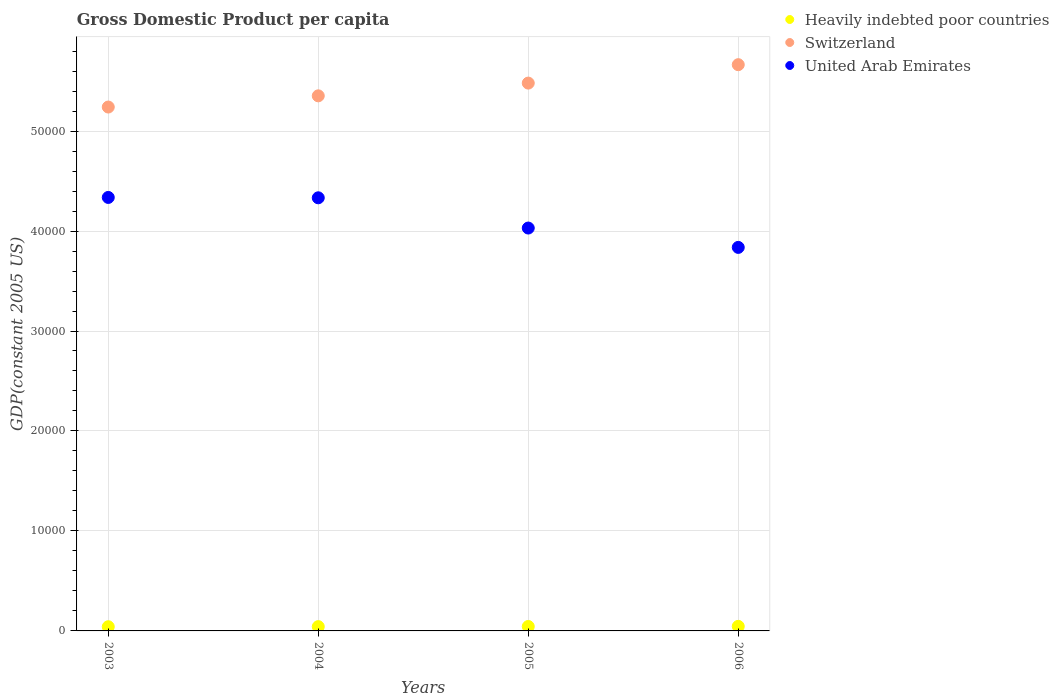How many different coloured dotlines are there?
Give a very brief answer. 3. What is the GDP per capita in Switzerland in 2004?
Make the answer very short. 5.35e+04. Across all years, what is the maximum GDP per capita in Switzerland?
Your answer should be compact. 5.66e+04. Across all years, what is the minimum GDP per capita in Switzerland?
Offer a terse response. 5.24e+04. In which year was the GDP per capita in United Arab Emirates maximum?
Your response must be concise. 2003. In which year was the GDP per capita in United Arab Emirates minimum?
Keep it short and to the point. 2006. What is the total GDP per capita in Switzerland in the graph?
Give a very brief answer. 2.17e+05. What is the difference between the GDP per capita in Heavily indebted poor countries in 2004 and that in 2006?
Keep it short and to the point. -26.72. What is the difference between the GDP per capita in Heavily indebted poor countries in 2006 and the GDP per capita in United Arab Emirates in 2004?
Offer a terse response. -4.29e+04. What is the average GDP per capita in Switzerland per year?
Make the answer very short. 5.43e+04. In the year 2005, what is the difference between the GDP per capita in Switzerland and GDP per capita in Heavily indebted poor countries?
Provide a short and direct response. 5.44e+04. In how many years, is the GDP per capita in Heavily indebted poor countries greater than 10000 US$?
Offer a terse response. 0. What is the ratio of the GDP per capita in United Arab Emirates in 2004 to that in 2006?
Your response must be concise. 1.13. What is the difference between the highest and the second highest GDP per capita in Switzerland?
Ensure brevity in your answer.  1842.34. What is the difference between the highest and the lowest GDP per capita in Switzerland?
Your answer should be compact. 4236.97. In how many years, is the GDP per capita in Heavily indebted poor countries greater than the average GDP per capita in Heavily indebted poor countries taken over all years?
Offer a terse response. 2. Is the sum of the GDP per capita in United Arab Emirates in 2003 and 2006 greater than the maximum GDP per capita in Switzerland across all years?
Make the answer very short. Yes. Is it the case that in every year, the sum of the GDP per capita in Switzerland and GDP per capita in Heavily indebted poor countries  is greater than the GDP per capita in United Arab Emirates?
Offer a very short reply. Yes. How many dotlines are there?
Provide a short and direct response. 3. What is the difference between two consecutive major ticks on the Y-axis?
Offer a terse response. 10000. Are the values on the major ticks of Y-axis written in scientific E-notation?
Offer a very short reply. No. Does the graph contain grids?
Keep it short and to the point. Yes. How are the legend labels stacked?
Your response must be concise. Vertical. What is the title of the graph?
Provide a succinct answer. Gross Domestic Product per capita. Does "Central Europe" appear as one of the legend labels in the graph?
Your response must be concise. No. What is the label or title of the X-axis?
Ensure brevity in your answer.  Years. What is the label or title of the Y-axis?
Offer a very short reply. GDP(constant 2005 US). What is the GDP(constant 2005 US) of Heavily indebted poor countries in 2003?
Make the answer very short. 419.1. What is the GDP(constant 2005 US) in Switzerland in 2003?
Ensure brevity in your answer.  5.24e+04. What is the GDP(constant 2005 US) in United Arab Emirates in 2003?
Offer a terse response. 4.34e+04. What is the GDP(constant 2005 US) of Heavily indebted poor countries in 2004?
Your answer should be very brief. 429.73. What is the GDP(constant 2005 US) in Switzerland in 2004?
Offer a very short reply. 5.35e+04. What is the GDP(constant 2005 US) of United Arab Emirates in 2004?
Offer a very short reply. 4.33e+04. What is the GDP(constant 2005 US) in Heavily indebted poor countries in 2005?
Ensure brevity in your answer.  443.25. What is the GDP(constant 2005 US) of Switzerland in 2005?
Ensure brevity in your answer.  5.48e+04. What is the GDP(constant 2005 US) of United Arab Emirates in 2005?
Your answer should be very brief. 4.03e+04. What is the GDP(constant 2005 US) in Heavily indebted poor countries in 2006?
Your response must be concise. 456.45. What is the GDP(constant 2005 US) in Switzerland in 2006?
Make the answer very short. 5.66e+04. What is the GDP(constant 2005 US) in United Arab Emirates in 2006?
Give a very brief answer. 3.84e+04. Across all years, what is the maximum GDP(constant 2005 US) in Heavily indebted poor countries?
Give a very brief answer. 456.45. Across all years, what is the maximum GDP(constant 2005 US) of Switzerland?
Offer a terse response. 5.66e+04. Across all years, what is the maximum GDP(constant 2005 US) of United Arab Emirates?
Give a very brief answer. 4.34e+04. Across all years, what is the minimum GDP(constant 2005 US) in Heavily indebted poor countries?
Your response must be concise. 419.1. Across all years, what is the minimum GDP(constant 2005 US) in Switzerland?
Provide a succinct answer. 5.24e+04. Across all years, what is the minimum GDP(constant 2005 US) of United Arab Emirates?
Make the answer very short. 3.84e+04. What is the total GDP(constant 2005 US) in Heavily indebted poor countries in the graph?
Your answer should be compact. 1748.53. What is the total GDP(constant 2005 US) in Switzerland in the graph?
Provide a short and direct response. 2.17e+05. What is the total GDP(constant 2005 US) of United Arab Emirates in the graph?
Offer a very short reply. 1.65e+05. What is the difference between the GDP(constant 2005 US) of Heavily indebted poor countries in 2003 and that in 2004?
Your answer should be very brief. -10.63. What is the difference between the GDP(constant 2005 US) in Switzerland in 2003 and that in 2004?
Your answer should be very brief. -1120.59. What is the difference between the GDP(constant 2005 US) of United Arab Emirates in 2003 and that in 2004?
Give a very brief answer. 35.85. What is the difference between the GDP(constant 2005 US) of Heavily indebted poor countries in 2003 and that in 2005?
Provide a succinct answer. -24.15. What is the difference between the GDP(constant 2005 US) in Switzerland in 2003 and that in 2005?
Offer a terse response. -2394.63. What is the difference between the GDP(constant 2005 US) in United Arab Emirates in 2003 and that in 2005?
Make the answer very short. 3061.33. What is the difference between the GDP(constant 2005 US) of Heavily indebted poor countries in 2003 and that in 2006?
Provide a short and direct response. -37.35. What is the difference between the GDP(constant 2005 US) in Switzerland in 2003 and that in 2006?
Your response must be concise. -4236.97. What is the difference between the GDP(constant 2005 US) in United Arab Emirates in 2003 and that in 2006?
Give a very brief answer. 4996.85. What is the difference between the GDP(constant 2005 US) in Heavily indebted poor countries in 2004 and that in 2005?
Ensure brevity in your answer.  -13.52. What is the difference between the GDP(constant 2005 US) of Switzerland in 2004 and that in 2005?
Your answer should be very brief. -1274.05. What is the difference between the GDP(constant 2005 US) of United Arab Emirates in 2004 and that in 2005?
Your answer should be compact. 3025.48. What is the difference between the GDP(constant 2005 US) of Heavily indebted poor countries in 2004 and that in 2006?
Your answer should be compact. -26.72. What is the difference between the GDP(constant 2005 US) in Switzerland in 2004 and that in 2006?
Provide a succinct answer. -3116.39. What is the difference between the GDP(constant 2005 US) in United Arab Emirates in 2004 and that in 2006?
Your answer should be compact. 4961. What is the difference between the GDP(constant 2005 US) in Heavily indebted poor countries in 2005 and that in 2006?
Ensure brevity in your answer.  -13.2. What is the difference between the GDP(constant 2005 US) in Switzerland in 2005 and that in 2006?
Provide a succinct answer. -1842.34. What is the difference between the GDP(constant 2005 US) of United Arab Emirates in 2005 and that in 2006?
Your answer should be compact. 1935.52. What is the difference between the GDP(constant 2005 US) in Heavily indebted poor countries in 2003 and the GDP(constant 2005 US) in Switzerland in 2004?
Offer a terse response. -5.31e+04. What is the difference between the GDP(constant 2005 US) of Heavily indebted poor countries in 2003 and the GDP(constant 2005 US) of United Arab Emirates in 2004?
Your answer should be compact. -4.29e+04. What is the difference between the GDP(constant 2005 US) in Switzerland in 2003 and the GDP(constant 2005 US) in United Arab Emirates in 2004?
Give a very brief answer. 9078.91. What is the difference between the GDP(constant 2005 US) in Heavily indebted poor countries in 2003 and the GDP(constant 2005 US) in Switzerland in 2005?
Your response must be concise. -5.44e+04. What is the difference between the GDP(constant 2005 US) in Heavily indebted poor countries in 2003 and the GDP(constant 2005 US) in United Arab Emirates in 2005?
Your answer should be very brief. -3.99e+04. What is the difference between the GDP(constant 2005 US) of Switzerland in 2003 and the GDP(constant 2005 US) of United Arab Emirates in 2005?
Keep it short and to the point. 1.21e+04. What is the difference between the GDP(constant 2005 US) of Heavily indebted poor countries in 2003 and the GDP(constant 2005 US) of Switzerland in 2006?
Offer a very short reply. -5.62e+04. What is the difference between the GDP(constant 2005 US) in Heavily indebted poor countries in 2003 and the GDP(constant 2005 US) in United Arab Emirates in 2006?
Give a very brief answer. -3.79e+04. What is the difference between the GDP(constant 2005 US) in Switzerland in 2003 and the GDP(constant 2005 US) in United Arab Emirates in 2006?
Your response must be concise. 1.40e+04. What is the difference between the GDP(constant 2005 US) in Heavily indebted poor countries in 2004 and the GDP(constant 2005 US) in Switzerland in 2005?
Your answer should be compact. -5.44e+04. What is the difference between the GDP(constant 2005 US) in Heavily indebted poor countries in 2004 and the GDP(constant 2005 US) in United Arab Emirates in 2005?
Your response must be concise. -3.99e+04. What is the difference between the GDP(constant 2005 US) in Switzerland in 2004 and the GDP(constant 2005 US) in United Arab Emirates in 2005?
Provide a short and direct response. 1.32e+04. What is the difference between the GDP(constant 2005 US) of Heavily indebted poor countries in 2004 and the GDP(constant 2005 US) of Switzerland in 2006?
Your response must be concise. -5.62e+04. What is the difference between the GDP(constant 2005 US) in Heavily indebted poor countries in 2004 and the GDP(constant 2005 US) in United Arab Emirates in 2006?
Keep it short and to the point. -3.79e+04. What is the difference between the GDP(constant 2005 US) of Switzerland in 2004 and the GDP(constant 2005 US) of United Arab Emirates in 2006?
Keep it short and to the point. 1.52e+04. What is the difference between the GDP(constant 2005 US) of Heavily indebted poor countries in 2005 and the GDP(constant 2005 US) of Switzerland in 2006?
Provide a short and direct response. -5.62e+04. What is the difference between the GDP(constant 2005 US) in Heavily indebted poor countries in 2005 and the GDP(constant 2005 US) in United Arab Emirates in 2006?
Make the answer very short. -3.79e+04. What is the difference between the GDP(constant 2005 US) of Switzerland in 2005 and the GDP(constant 2005 US) of United Arab Emirates in 2006?
Provide a succinct answer. 1.64e+04. What is the average GDP(constant 2005 US) in Heavily indebted poor countries per year?
Offer a very short reply. 437.13. What is the average GDP(constant 2005 US) in Switzerland per year?
Offer a very short reply. 5.43e+04. What is the average GDP(constant 2005 US) in United Arab Emirates per year?
Your answer should be very brief. 4.13e+04. In the year 2003, what is the difference between the GDP(constant 2005 US) of Heavily indebted poor countries and GDP(constant 2005 US) of Switzerland?
Offer a terse response. -5.20e+04. In the year 2003, what is the difference between the GDP(constant 2005 US) of Heavily indebted poor countries and GDP(constant 2005 US) of United Arab Emirates?
Your answer should be very brief. -4.29e+04. In the year 2003, what is the difference between the GDP(constant 2005 US) of Switzerland and GDP(constant 2005 US) of United Arab Emirates?
Make the answer very short. 9043.06. In the year 2004, what is the difference between the GDP(constant 2005 US) in Heavily indebted poor countries and GDP(constant 2005 US) in Switzerland?
Provide a succinct answer. -5.31e+04. In the year 2004, what is the difference between the GDP(constant 2005 US) in Heavily indebted poor countries and GDP(constant 2005 US) in United Arab Emirates?
Ensure brevity in your answer.  -4.29e+04. In the year 2004, what is the difference between the GDP(constant 2005 US) in Switzerland and GDP(constant 2005 US) in United Arab Emirates?
Offer a terse response. 1.02e+04. In the year 2005, what is the difference between the GDP(constant 2005 US) of Heavily indebted poor countries and GDP(constant 2005 US) of Switzerland?
Your answer should be very brief. -5.44e+04. In the year 2005, what is the difference between the GDP(constant 2005 US) of Heavily indebted poor countries and GDP(constant 2005 US) of United Arab Emirates?
Ensure brevity in your answer.  -3.99e+04. In the year 2005, what is the difference between the GDP(constant 2005 US) of Switzerland and GDP(constant 2005 US) of United Arab Emirates?
Your response must be concise. 1.45e+04. In the year 2006, what is the difference between the GDP(constant 2005 US) in Heavily indebted poor countries and GDP(constant 2005 US) in Switzerland?
Your answer should be very brief. -5.62e+04. In the year 2006, what is the difference between the GDP(constant 2005 US) of Heavily indebted poor countries and GDP(constant 2005 US) of United Arab Emirates?
Your answer should be very brief. -3.79e+04. In the year 2006, what is the difference between the GDP(constant 2005 US) of Switzerland and GDP(constant 2005 US) of United Arab Emirates?
Provide a short and direct response. 1.83e+04. What is the ratio of the GDP(constant 2005 US) in Heavily indebted poor countries in 2003 to that in 2004?
Your answer should be very brief. 0.98. What is the ratio of the GDP(constant 2005 US) of Switzerland in 2003 to that in 2004?
Provide a succinct answer. 0.98. What is the ratio of the GDP(constant 2005 US) of United Arab Emirates in 2003 to that in 2004?
Make the answer very short. 1. What is the ratio of the GDP(constant 2005 US) of Heavily indebted poor countries in 2003 to that in 2005?
Ensure brevity in your answer.  0.95. What is the ratio of the GDP(constant 2005 US) in Switzerland in 2003 to that in 2005?
Give a very brief answer. 0.96. What is the ratio of the GDP(constant 2005 US) of United Arab Emirates in 2003 to that in 2005?
Provide a short and direct response. 1.08. What is the ratio of the GDP(constant 2005 US) in Heavily indebted poor countries in 2003 to that in 2006?
Offer a very short reply. 0.92. What is the ratio of the GDP(constant 2005 US) in Switzerland in 2003 to that in 2006?
Your response must be concise. 0.93. What is the ratio of the GDP(constant 2005 US) in United Arab Emirates in 2003 to that in 2006?
Ensure brevity in your answer.  1.13. What is the ratio of the GDP(constant 2005 US) in Heavily indebted poor countries in 2004 to that in 2005?
Offer a terse response. 0.97. What is the ratio of the GDP(constant 2005 US) of Switzerland in 2004 to that in 2005?
Ensure brevity in your answer.  0.98. What is the ratio of the GDP(constant 2005 US) in United Arab Emirates in 2004 to that in 2005?
Your answer should be compact. 1.08. What is the ratio of the GDP(constant 2005 US) of Heavily indebted poor countries in 2004 to that in 2006?
Make the answer very short. 0.94. What is the ratio of the GDP(constant 2005 US) of Switzerland in 2004 to that in 2006?
Provide a short and direct response. 0.94. What is the ratio of the GDP(constant 2005 US) in United Arab Emirates in 2004 to that in 2006?
Your answer should be very brief. 1.13. What is the ratio of the GDP(constant 2005 US) in Heavily indebted poor countries in 2005 to that in 2006?
Provide a succinct answer. 0.97. What is the ratio of the GDP(constant 2005 US) in Switzerland in 2005 to that in 2006?
Give a very brief answer. 0.97. What is the ratio of the GDP(constant 2005 US) in United Arab Emirates in 2005 to that in 2006?
Offer a very short reply. 1.05. What is the difference between the highest and the second highest GDP(constant 2005 US) of Heavily indebted poor countries?
Your response must be concise. 13.2. What is the difference between the highest and the second highest GDP(constant 2005 US) of Switzerland?
Offer a very short reply. 1842.34. What is the difference between the highest and the second highest GDP(constant 2005 US) of United Arab Emirates?
Your response must be concise. 35.85. What is the difference between the highest and the lowest GDP(constant 2005 US) of Heavily indebted poor countries?
Your answer should be very brief. 37.35. What is the difference between the highest and the lowest GDP(constant 2005 US) in Switzerland?
Your answer should be very brief. 4236.97. What is the difference between the highest and the lowest GDP(constant 2005 US) in United Arab Emirates?
Make the answer very short. 4996.85. 